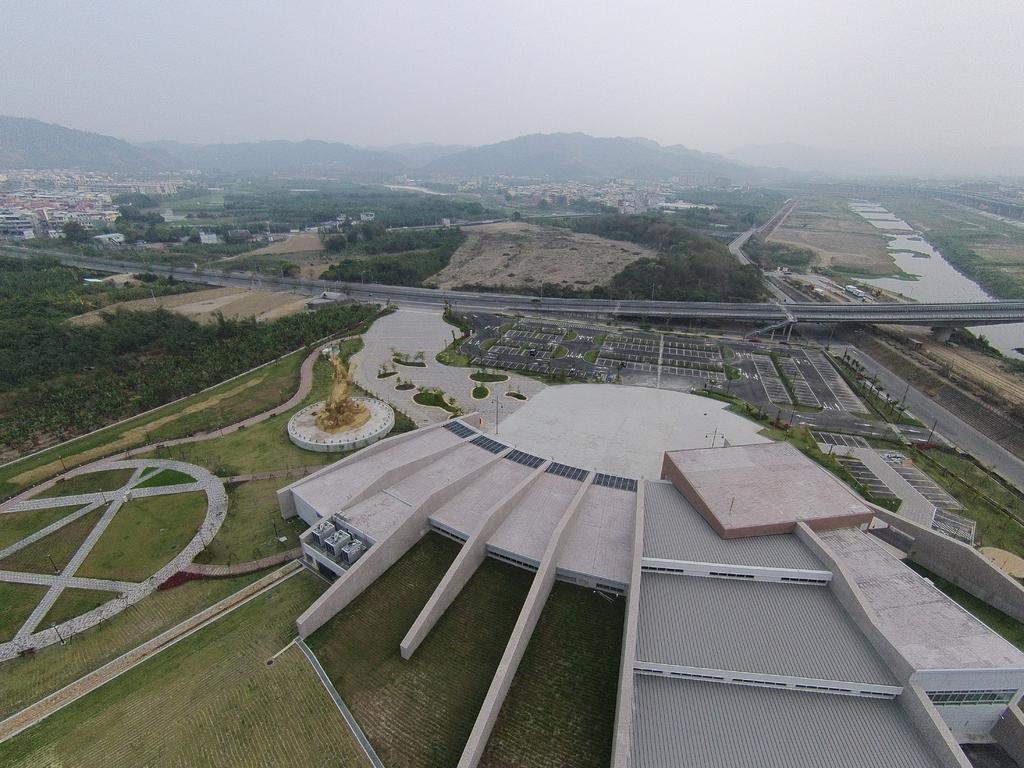What type of structures can be seen in the image? There are buildings in the image. What natural elements are present in the image? There are trees, grass, and water in the image. Can you describe the sculpture in the image? There is a sculpture in the image, but its specific details are not mentioned in the facts. What is the surface that vehicles might travel on in the image? This is a road in the image. What is visible in the background of the image? There is a mountain and the sky in the background of the image. How many girls are present in the image? There is no mention of girls in the image, so we cannot determine their presence or number. What is the texture of the fear in the image? There is no fear present in the image, so we cannot determine its texture. 